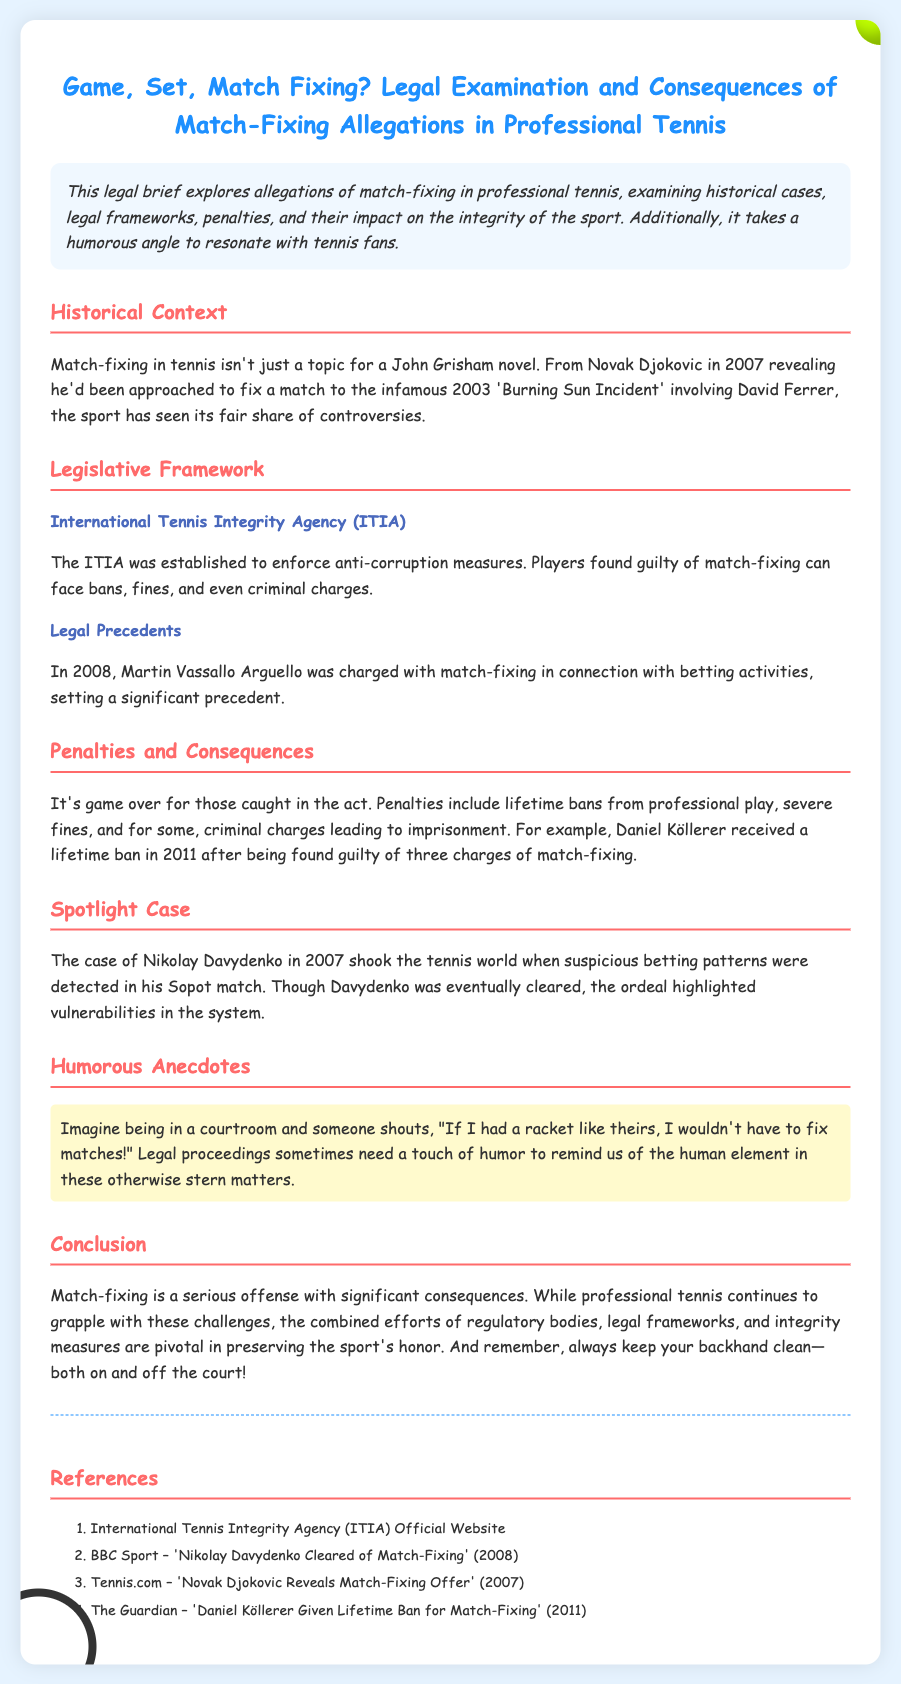What was the year of the 'Burning Sun Incident'? The incident involving David Ferrer occurred in 2003, as mentioned in the historical context.
Answer: 2003 Who revealed he was approached to fix a match in 2007? According to the document, Novak Djokovic disclosed this information.
Answer: Novak Djokovic What organization was established to enforce anti-corruption measures? The International Tennis Integrity Agency (ITIA) is responsible for this, as detailed in the legislative framework section.
Answer: International Tennis Integrity Agency (ITIA) What penalty did Daniel Köllerer receive in 2011? The document states he received a lifetime ban for match-fixing.
Answer: Lifetime ban Which player's case involved suspicious betting patterns in Sopot? The case highlighted in the document pertains to Nikolay Davydenko.
Answer: Nikolay Davydenko What year was Martin Vassallo Arguello charged with match-fixing? The legal precedent indicates this charge was made in 2008.
Answer: 2008 What humorous anecdote is mentioned regarding court proceedings? It implies a humorous shout about rackets in the courtroom context.
Answer: "If I had a racket like theirs, I wouldn't have to fix matches!" What is the overarching theme of the brief? The focus is on the legal examination and consequences of match-fixing allegations in professional tennis.
Answer: Legal examination and consequences of match-fixing 